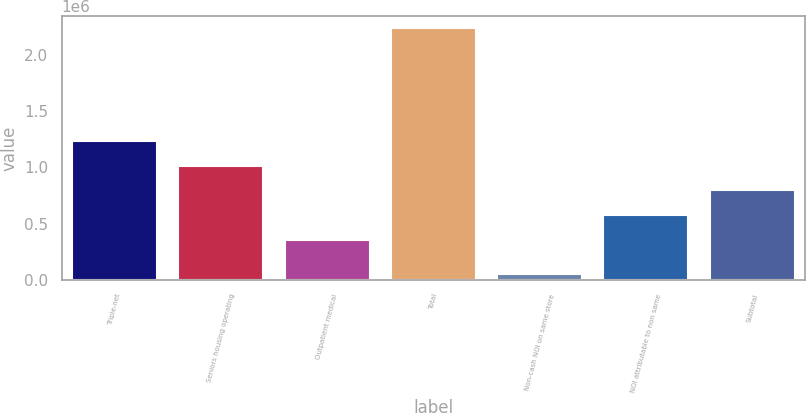Convert chart. <chart><loc_0><loc_0><loc_500><loc_500><bar_chart><fcel>Triple-net<fcel>Seniors housing operating<fcel>Outpatient medical<fcel>Total<fcel>Non-cash NOI on same store<fcel>NOI attributable to non same<fcel>Subtotal<nl><fcel>1.23445e+06<fcel>1.01569e+06<fcel>359410<fcel>2.23648e+06<fcel>48890<fcel>578169<fcel>796928<nl></chart> 